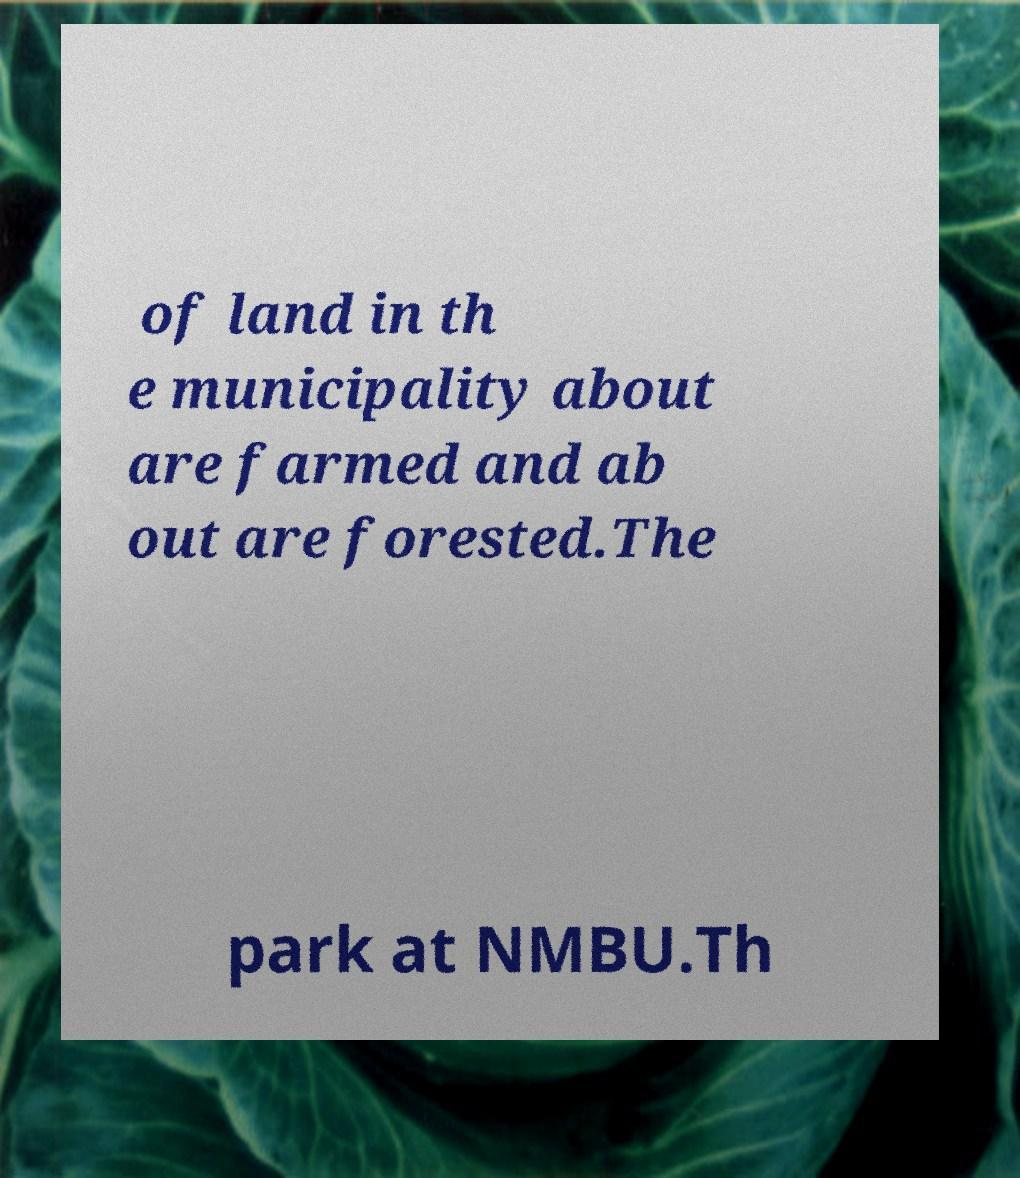What messages or text are displayed in this image? I need them in a readable, typed format. of land in th e municipality about are farmed and ab out are forested.The park at NMBU.Th 